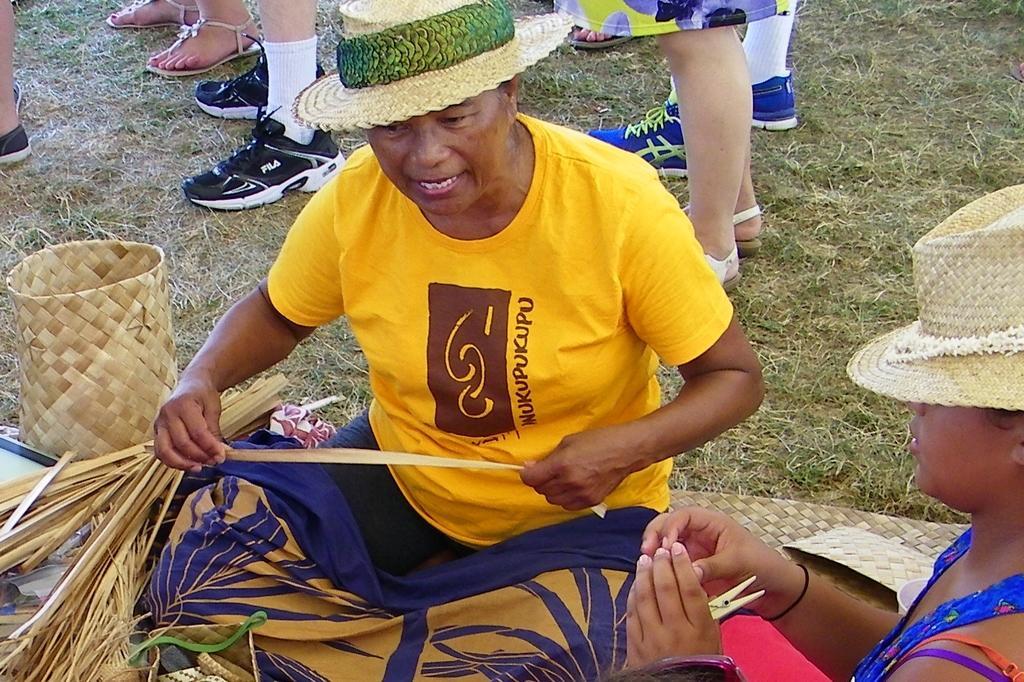Describe this image in one or two sentences. In this picture I can see a group of people among them two persons are sitting. This person is holding some object in the hand and these two people are wearing hats. On the left side I can see some wooden objects and grass. In the background I can see footwear's. 